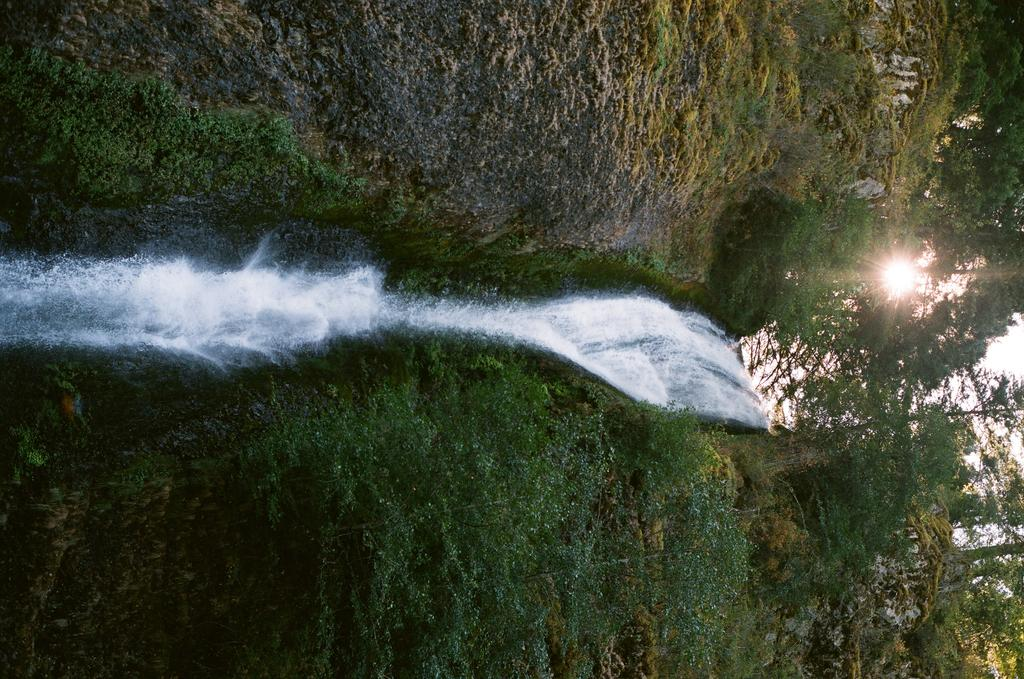What natural feature is located at the front of the image? There is a small waterfall in the front of the image. What type of vegetation surrounds the waterfall? There are trees on both sides of the waterfall. What can be seen at the top of the image? The sky is visible at the top of the image. What celestial body is present in the sky? The sun is present in the sky. What type of engine is powering the waterfall in the image? There is no engine present in the image; the waterfall is a natural feature powered by gravity and water flow. 